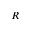<formula> <loc_0><loc_0><loc_500><loc_500>R</formula> 